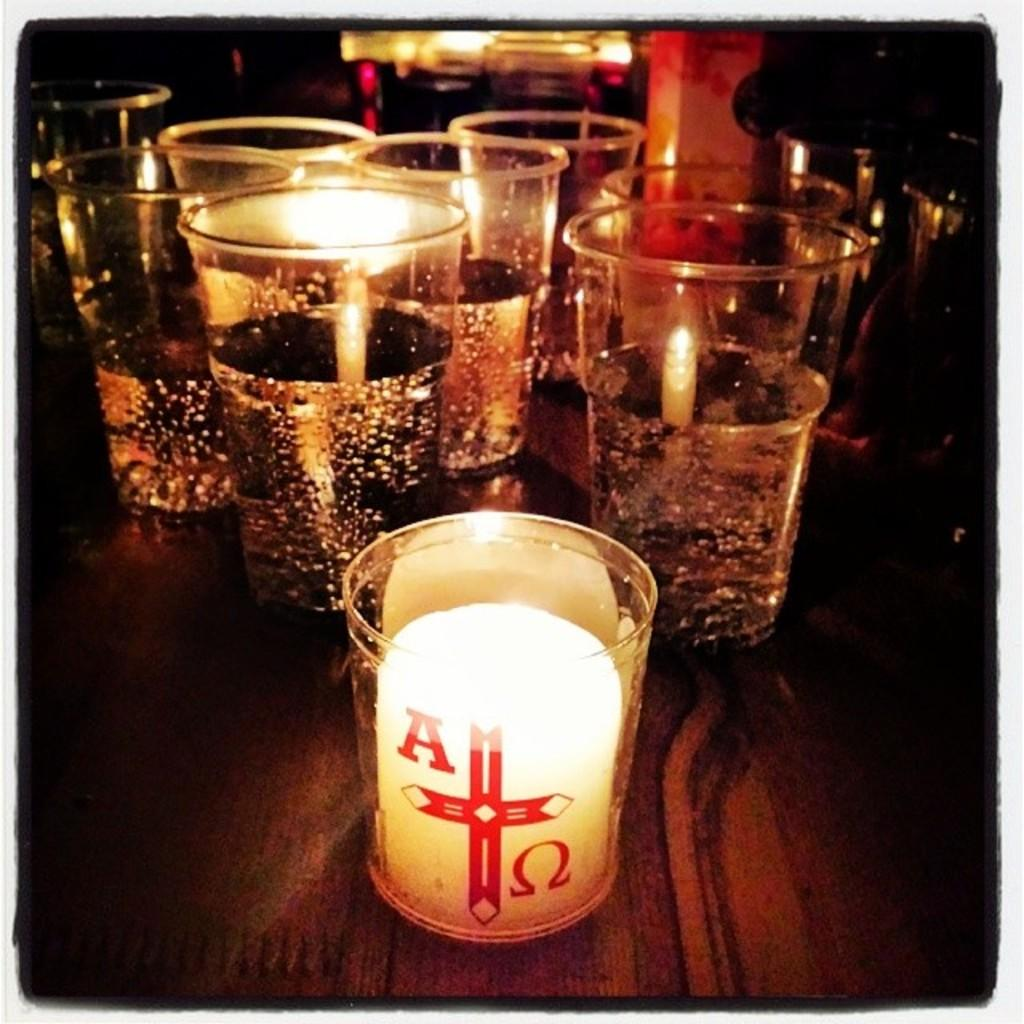<image>
Write a terse but informative summary of the picture. A candle lite in a glass with A red cross in the middle with 6 more candles in the back 